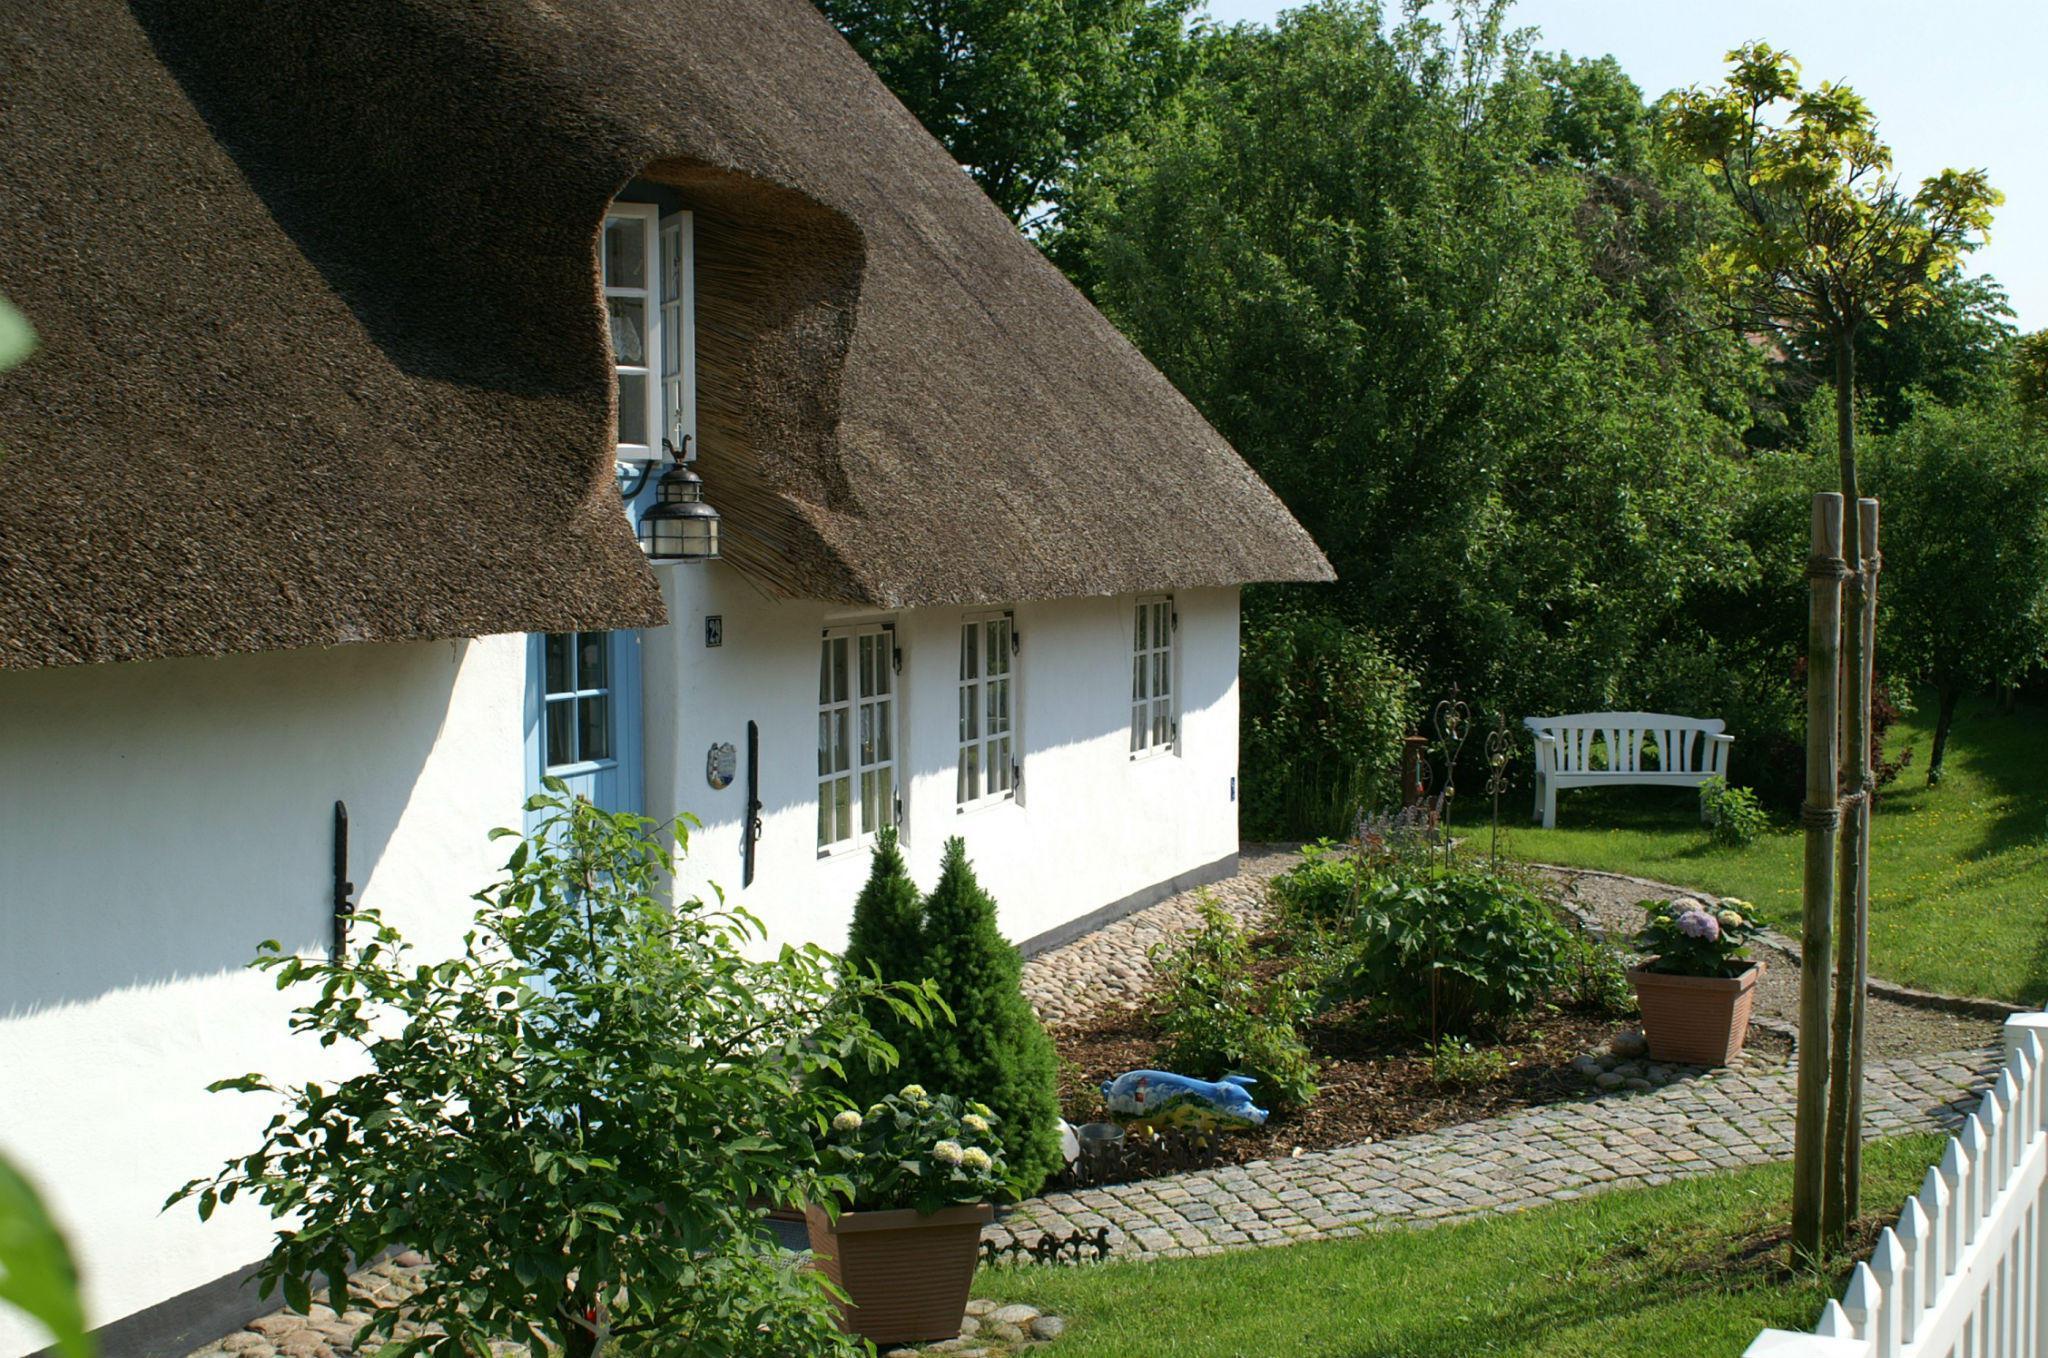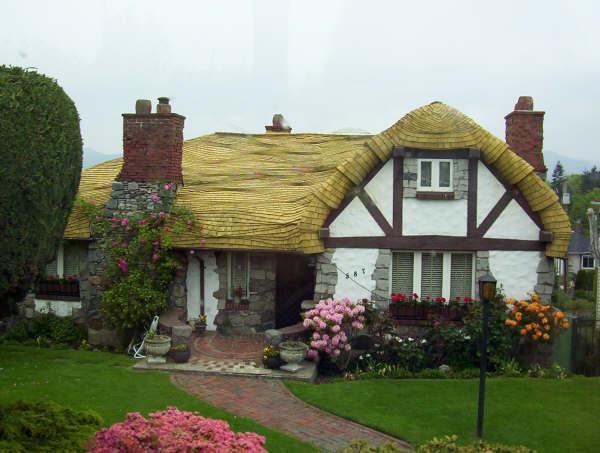The first image is the image on the left, the second image is the image on the right. For the images shown, is this caption "in at least one image there is a house with a gray roof slanted facing left." true? Answer yes or no. No. 